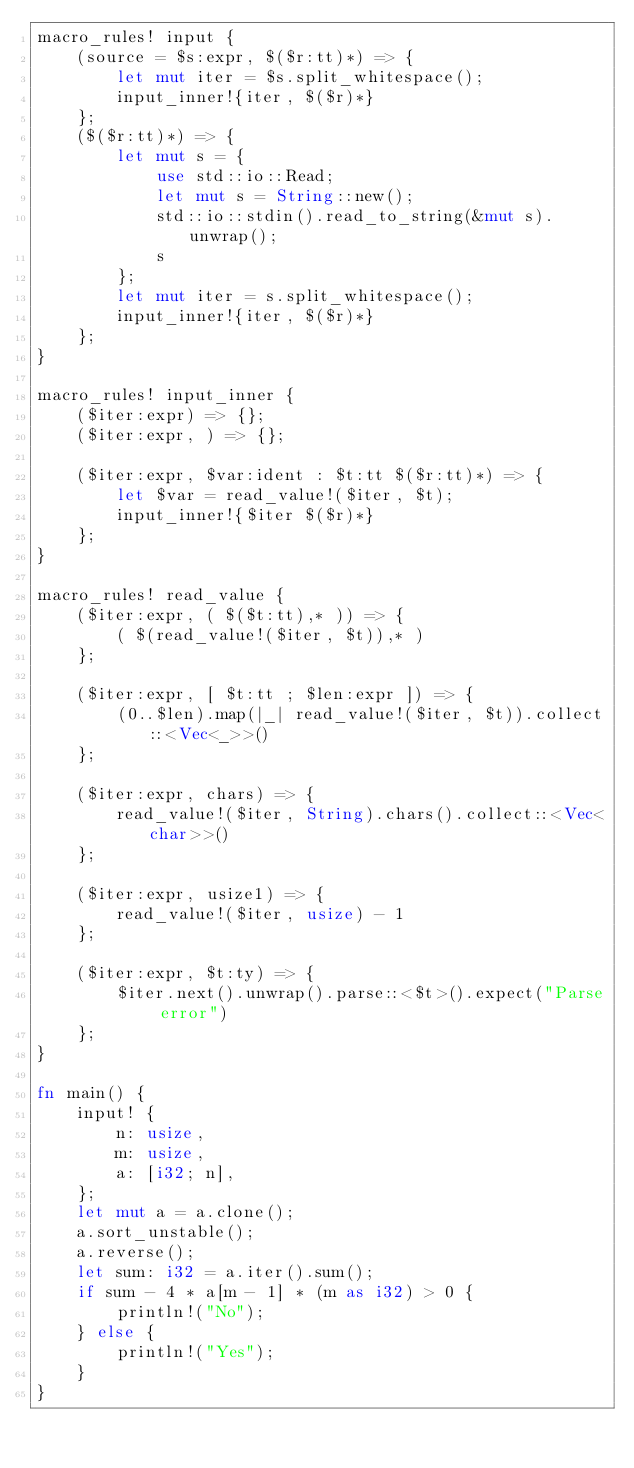<code> <loc_0><loc_0><loc_500><loc_500><_Rust_>macro_rules! input {
    (source = $s:expr, $($r:tt)*) => {
        let mut iter = $s.split_whitespace();
        input_inner!{iter, $($r)*}
    };
    ($($r:tt)*) => {
        let mut s = {
            use std::io::Read;
            let mut s = String::new();
            std::io::stdin().read_to_string(&mut s).unwrap();
            s
        };
        let mut iter = s.split_whitespace();
        input_inner!{iter, $($r)*}
    };
}

macro_rules! input_inner {
    ($iter:expr) => {};
    ($iter:expr, ) => {};

    ($iter:expr, $var:ident : $t:tt $($r:tt)*) => {
        let $var = read_value!($iter, $t);
        input_inner!{$iter $($r)*}
    };
}

macro_rules! read_value {
    ($iter:expr, ( $($t:tt),* )) => {
        ( $(read_value!($iter, $t)),* )
    };

    ($iter:expr, [ $t:tt ; $len:expr ]) => {
        (0..$len).map(|_| read_value!($iter, $t)).collect::<Vec<_>>()
    };

    ($iter:expr, chars) => {
        read_value!($iter, String).chars().collect::<Vec<char>>()
    };

    ($iter:expr, usize1) => {
        read_value!($iter, usize) - 1
    };

    ($iter:expr, $t:ty) => {
        $iter.next().unwrap().parse::<$t>().expect("Parse error")
    };
}

fn main() {
    input! {
        n: usize,
        m: usize,
        a: [i32; n],
    };
    let mut a = a.clone();
    a.sort_unstable();
    a.reverse();
    let sum: i32 = a.iter().sum();
    if sum - 4 * a[m - 1] * (m as i32) > 0 {
        println!("No");
    } else {
        println!("Yes");
    }
}
</code> 